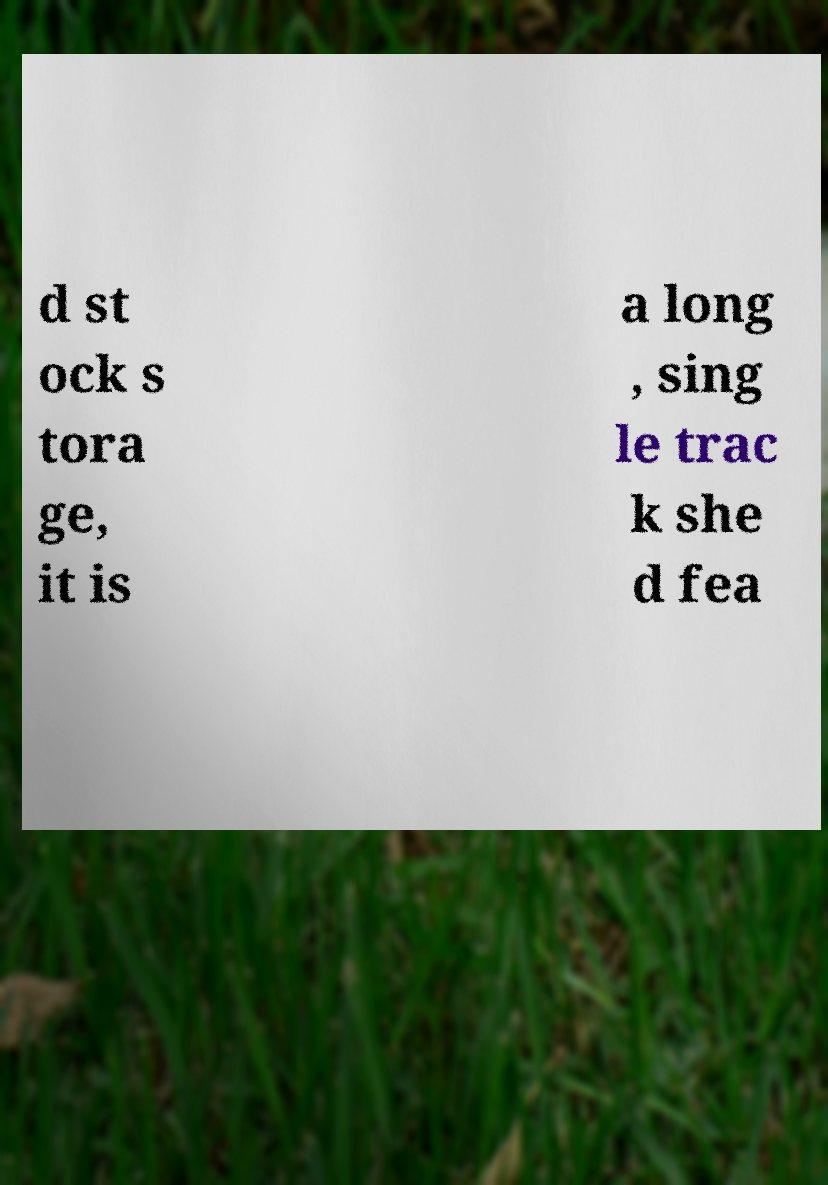Can you accurately transcribe the text from the provided image for me? d st ock s tora ge, it is a long , sing le trac k she d fea 